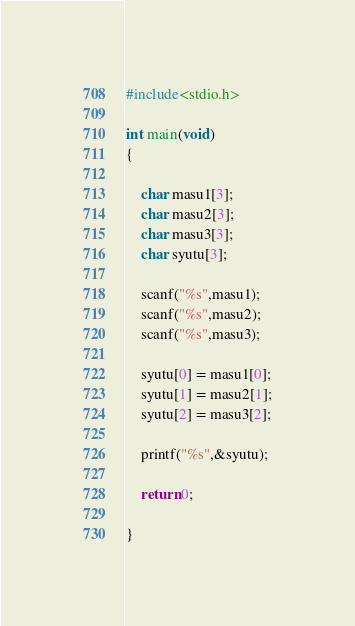Convert code to text. <code><loc_0><loc_0><loc_500><loc_500><_C_>#include<stdio.h>

int main(void)
{
	
	char masu1[3];
	char masu2[3];
	char masu3[3];
	char syutu[3];
	
	scanf("%s",masu1);
	scanf("%s",masu2);
	scanf("%s",masu3);
	
	syutu[0] = masu1[0];
	syutu[1] = masu2[1];
	syutu[2] = masu3[2];
	
	printf("%s",&syutu);
	
	return 0;
	
}</code> 